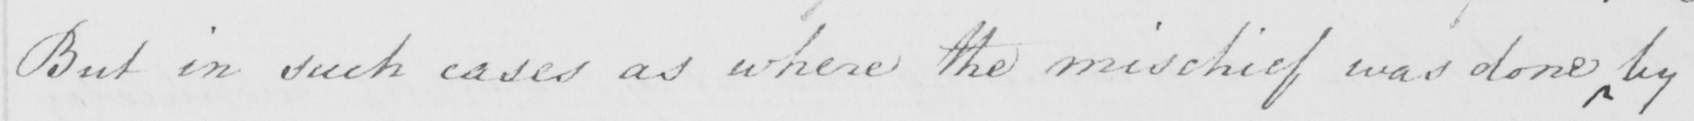What does this handwritten line say? But in such cases as where the mischief was done by 